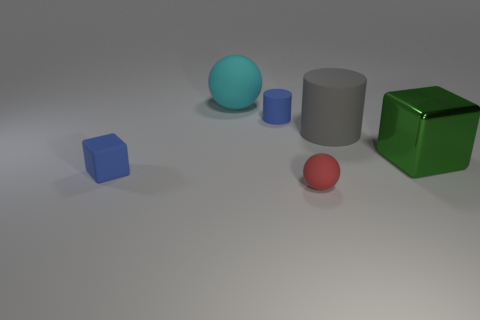Subtract all green cubes. How many cubes are left? 1 Subtract all spheres. How many objects are left? 4 Add 4 small shiny cylinders. How many objects exist? 10 Subtract 1 spheres. How many spheres are left? 1 Subtract all large cyan blocks. Subtract all small red spheres. How many objects are left? 5 Add 2 blue cubes. How many blue cubes are left? 3 Add 3 rubber things. How many rubber things exist? 8 Subtract 0 red cylinders. How many objects are left? 6 Subtract all gray cubes. Subtract all red cylinders. How many cubes are left? 2 